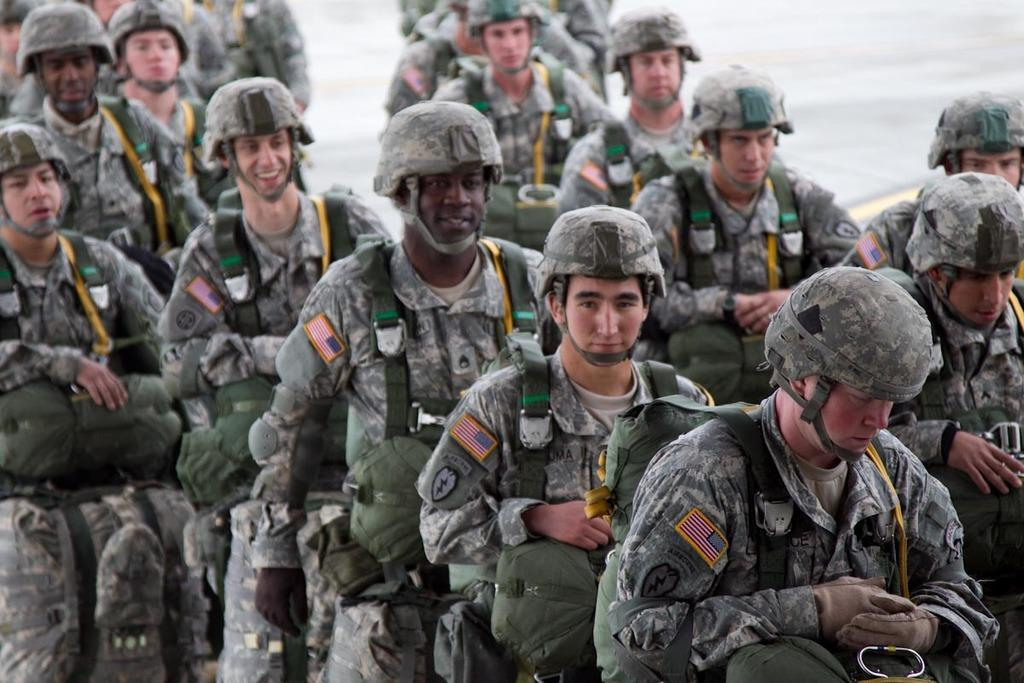What type of clothing are the people in the image wearing? The people in the image are wearing military uniforms. What are some people in the image carrying? Some people in the image are carrying bags. What type of feast is being prepared in the image? There is no feast being prepared in the image; it features people in military uniforms and some carrying bags. What is the weight of the school in the image? There is no school present in the image, so it is not possible to determine its weight. 